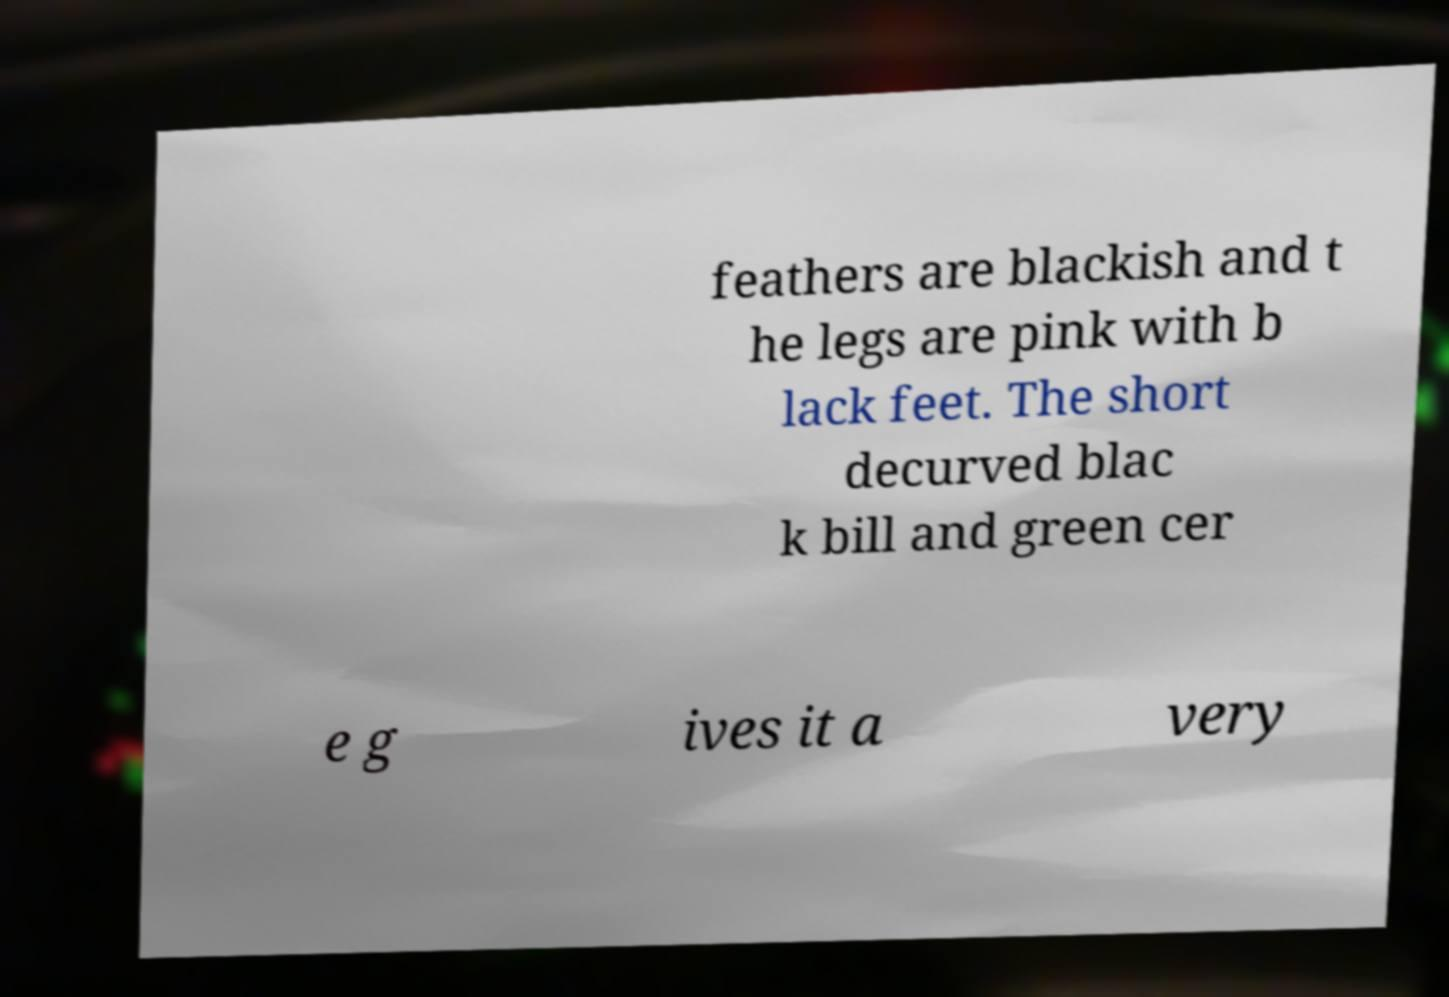Could you assist in decoding the text presented in this image and type it out clearly? feathers are blackish and t he legs are pink with b lack feet. The short decurved blac k bill and green cer e g ives it a very 